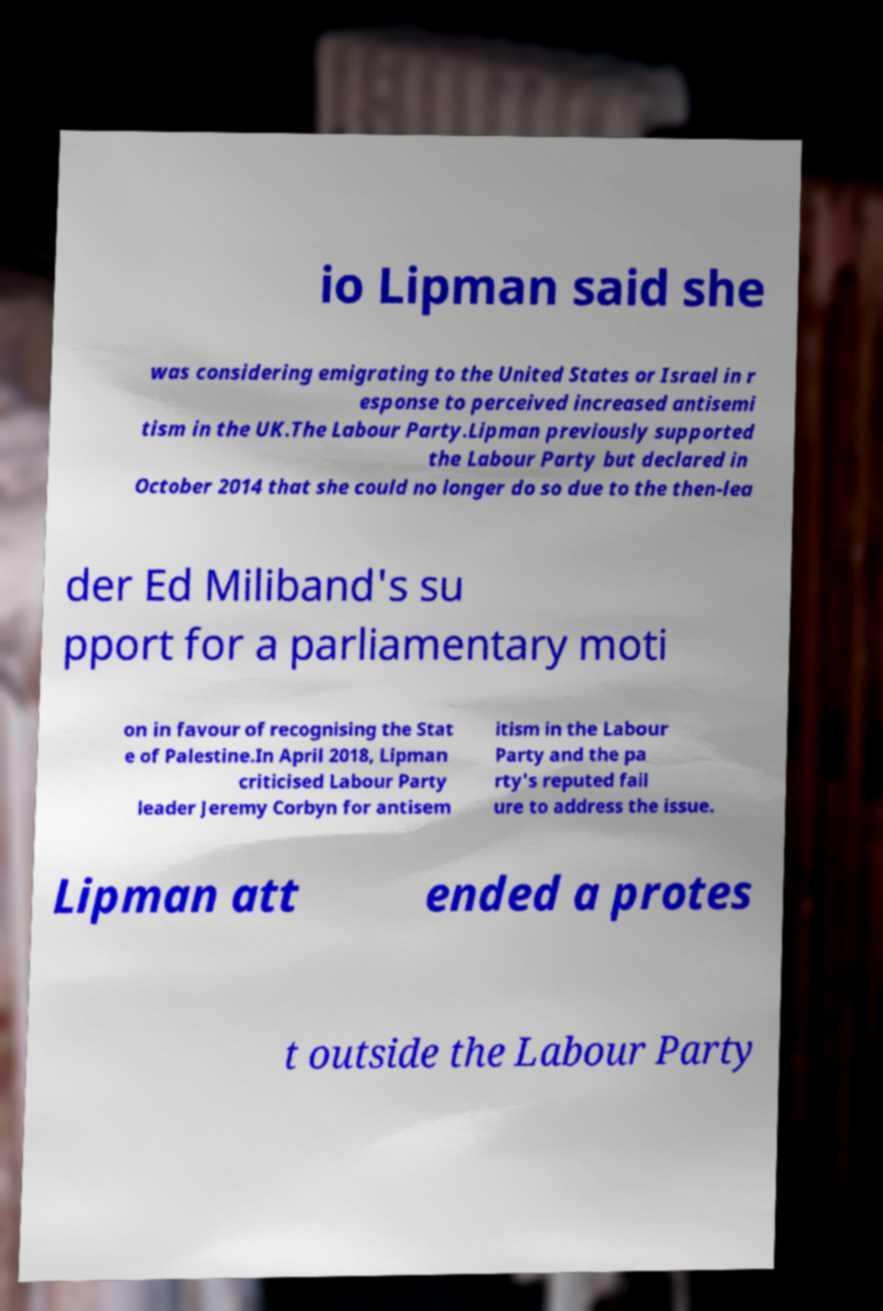I need the written content from this picture converted into text. Can you do that? io Lipman said she was considering emigrating to the United States or Israel in r esponse to perceived increased antisemi tism in the UK.The Labour Party.Lipman previously supported the Labour Party but declared in October 2014 that she could no longer do so due to the then-lea der Ed Miliband's su pport for a parliamentary moti on in favour of recognising the Stat e of Palestine.In April 2018, Lipman criticised Labour Party leader Jeremy Corbyn for antisem itism in the Labour Party and the pa rty's reputed fail ure to address the issue. Lipman att ended a protes t outside the Labour Party 